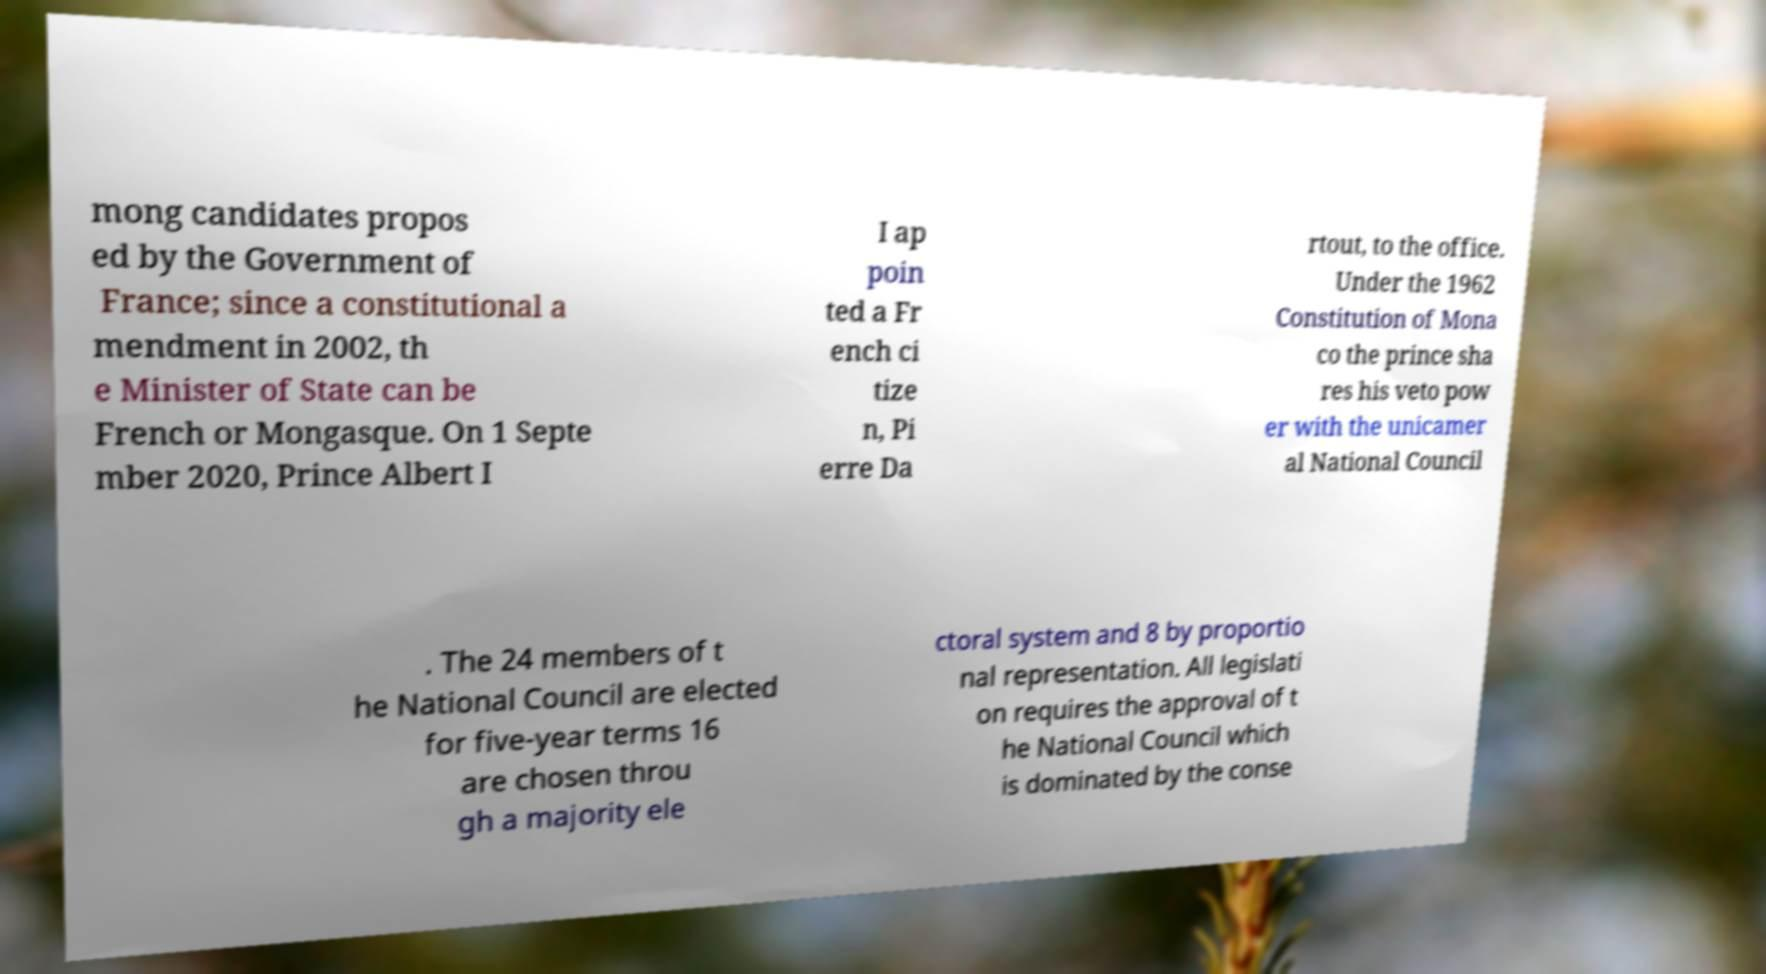Please read and relay the text visible in this image. What does it say? mong candidates propos ed by the Government of France; since a constitutional a mendment in 2002, th e Minister of State can be French or Mongasque. On 1 Septe mber 2020, Prince Albert I I ap poin ted a Fr ench ci tize n, Pi erre Da rtout, to the office. Under the 1962 Constitution of Mona co the prince sha res his veto pow er with the unicamer al National Council . The 24 members of t he National Council are elected for five-year terms 16 are chosen throu gh a majority ele ctoral system and 8 by proportio nal representation. All legislati on requires the approval of t he National Council which is dominated by the conse 